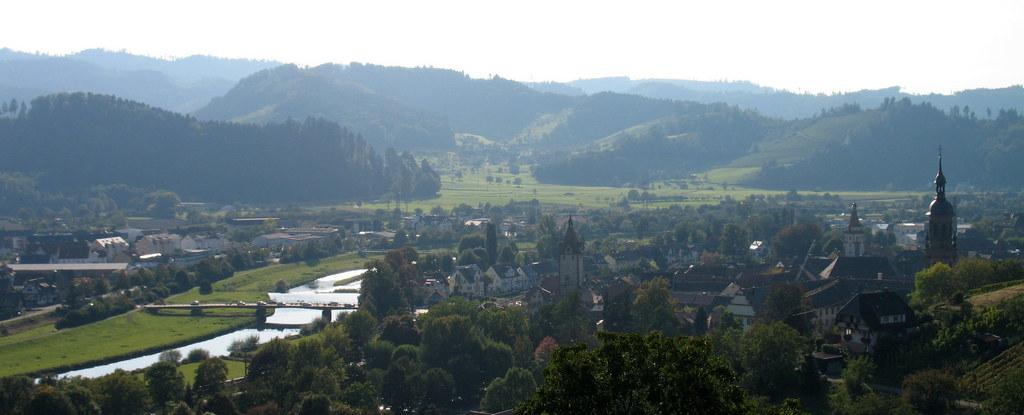What type of location is depicted in the image? The image depicts a village. What structures can be seen in the village? There are houses in the village. What type of vegetation is present in the village? There are trees in the village. What natural feature is visible in the image? There is a river in the image. What architectural feature is present in the image? There is a bridge in the image. What geographical feature is visible in the image? There are mountains in the image. What part of the natural environment is visible in the image? The sky is visible in the image. What type of vest is being worn by the river in the image? There is no vest present in the image, as the river is a natural feature and not a person or animal. 